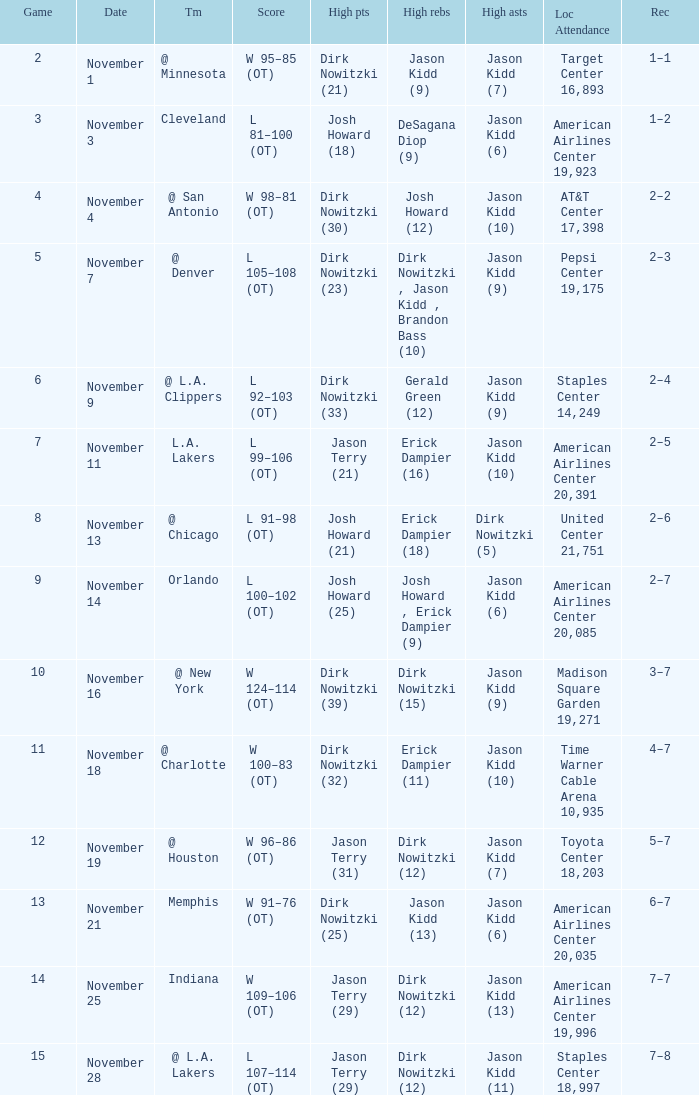What was the record on November 7? 1.0. 